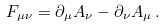Convert formula to latex. <formula><loc_0><loc_0><loc_500><loc_500>F _ { \mu \nu } = \partial _ { \mu } A _ { \nu } - \partial _ { \nu } A _ { \mu } \, .</formula> 